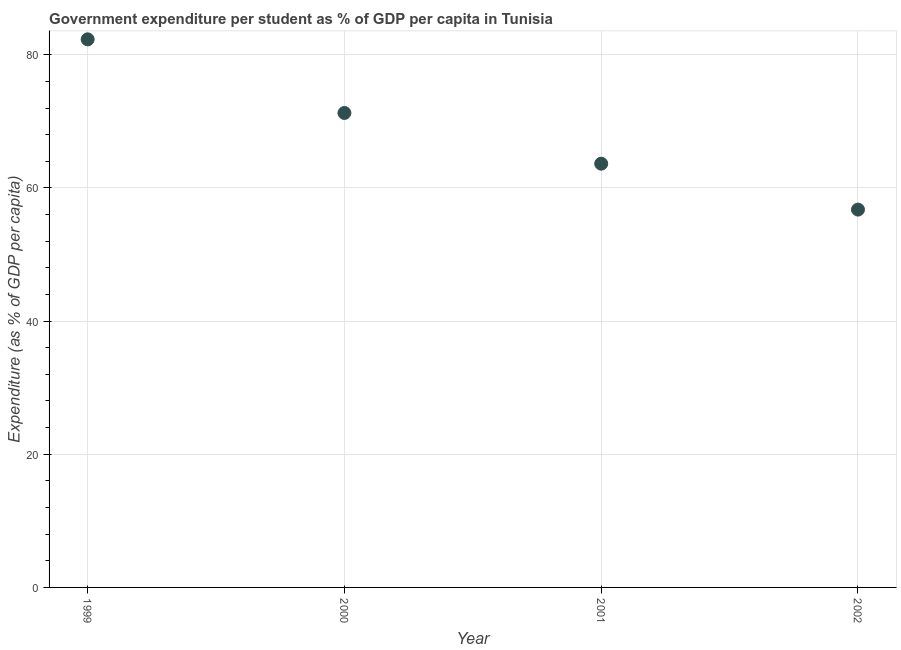What is the government expenditure per student in 2002?
Give a very brief answer. 56.74. Across all years, what is the maximum government expenditure per student?
Offer a very short reply. 82.31. Across all years, what is the minimum government expenditure per student?
Provide a succinct answer. 56.74. In which year was the government expenditure per student maximum?
Provide a succinct answer. 1999. What is the sum of the government expenditure per student?
Offer a very short reply. 273.95. What is the difference between the government expenditure per student in 2000 and 2001?
Give a very brief answer. 7.62. What is the average government expenditure per student per year?
Offer a very short reply. 68.49. What is the median government expenditure per student?
Your answer should be very brief. 67.45. In how many years, is the government expenditure per student greater than 12 %?
Offer a very short reply. 4. What is the ratio of the government expenditure per student in 2000 to that in 2001?
Make the answer very short. 1.12. Is the government expenditure per student in 2000 less than that in 2002?
Keep it short and to the point. No. What is the difference between the highest and the second highest government expenditure per student?
Keep it short and to the point. 11.06. What is the difference between the highest and the lowest government expenditure per student?
Offer a very short reply. 25.57. Does the government expenditure per student monotonically increase over the years?
Provide a succinct answer. No. How many years are there in the graph?
Your response must be concise. 4. What is the title of the graph?
Your response must be concise. Government expenditure per student as % of GDP per capita in Tunisia. What is the label or title of the X-axis?
Provide a succinct answer. Year. What is the label or title of the Y-axis?
Keep it short and to the point. Expenditure (as % of GDP per capita). What is the Expenditure (as % of GDP per capita) in 1999?
Provide a succinct answer. 82.31. What is the Expenditure (as % of GDP per capita) in 2000?
Your response must be concise. 71.26. What is the Expenditure (as % of GDP per capita) in 2001?
Your answer should be very brief. 63.64. What is the Expenditure (as % of GDP per capita) in 2002?
Ensure brevity in your answer.  56.74. What is the difference between the Expenditure (as % of GDP per capita) in 1999 and 2000?
Provide a short and direct response. 11.06. What is the difference between the Expenditure (as % of GDP per capita) in 1999 and 2001?
Offer a very short reply. 18.67. What is the difference between the Expenditure (as % of GDP per capita) in 1999 and 2002?
Ensure brevity in your answer.  25.57. What is the difference between the Expenditure (as % of GDP per capita) in 2000 and 2001?
Your answer should be very brief. 7.62. What is the difference between the Expenditure (as % of GDP per capita) in 2000 and 2002?
Provide a short and direct response. 14.51. What is the difference between the Expenditure (as % of GDP per capita) in 2001 and 2002?
Offer a very short reply. 6.9. What is the ratio of the Expenditure (as % of GDP per capita) in 1999 to that in 2000?
Ensure brevity in your answer.  1.16. What is the ratio of the Expenditure (as % of GDP per capita) in 1999 to that in 2001?
Your response must be concise. 1.29. What is the ratio of the Expenditure (as % of GDP per capita) in 1999 to that in 2002?
Offer a terse response. 1.45. What is the ratio of the Expenditure (as % of GDP per capita) in 2000 to that in 2001?
Your answer should be compact. 1.12. What is the ratio of the Expenditure (as % of GDP per capita) in 2000 to that in 2002?
Offer a very short reply. 1.26. What is the ratio of the Expenditure (as % of GDP per capita) in 2001 to that in 2002?
Keep it short and to the point. 1.12. 